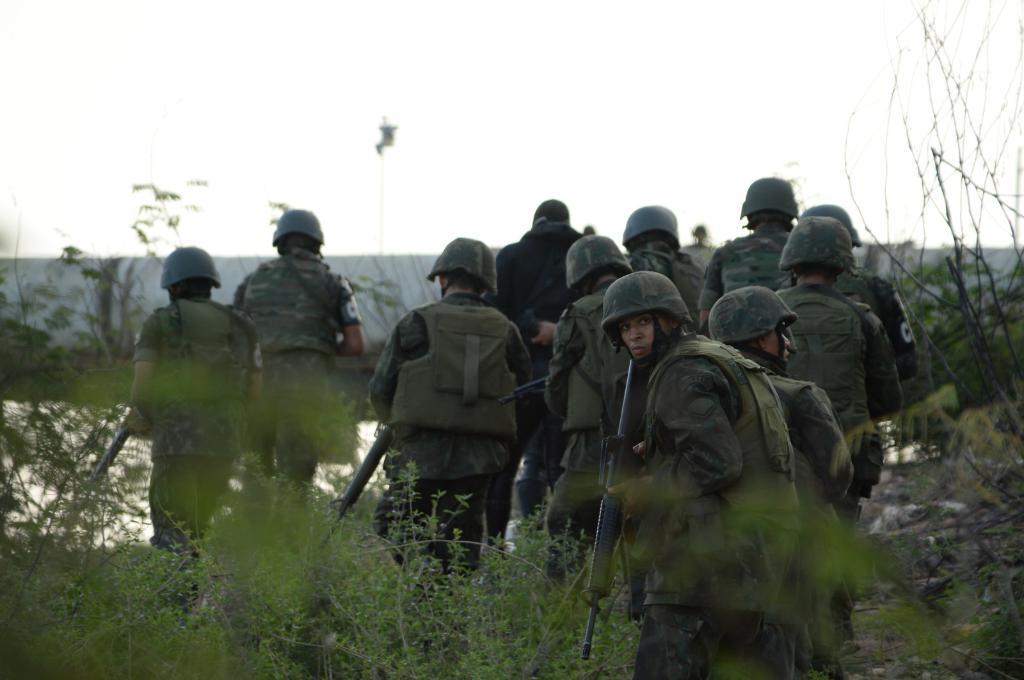Describe this image in one or two sentences. In this image I can see a group of people are walking on the ground and are holding guns in their hand. In the background I can see plants, water, tents and the sky. This image is taken may be during a day. 